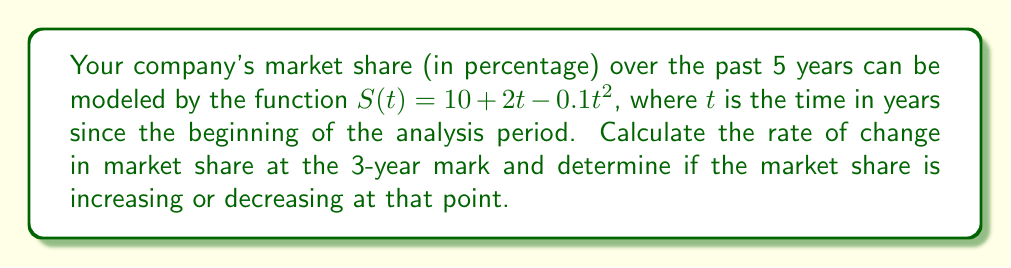Teach me how to tackle this problem. To solve this problem, we need to use derivatives to calculate the rate of change in market share.

1. The given function for market share is:
   $$S(t) = 10 + 2t - 0.1t^2$$

2. To find the rate of change, we need to calculate the first derivative of $S(t)$:
   $$S'(t) = 2 - 0.2t$$

3. The rate of change at the 3-year mark is found by evaluating $S'(3)$:
   $$S'(3) = 2 - 0.2(3) = 2 - 0.6 = 1.4$$

4. To determine if the market share is increasing or decreasing, we look at the sign of $S'(3)$:
   - If $S'(3) > 0$, the market share is increasing
   - If $S'(3) < 0$, the market share is decreasing
   - If $S'(3) = 0$, the market share is at a stationary point

   Since $S'(3) = 1.4 > 0$, the market share is increasing at the 3-year mark.

5. Interpretation:
   - The rate of change at the 3-year mark is 1.4 percentage points per year.
   - This positive value indicates that the market share is growing at that point in time.
Answer: The rate of change in market share at the 3-year mark is 1.4 percentage points per year, and the market share is increasing at that point. 